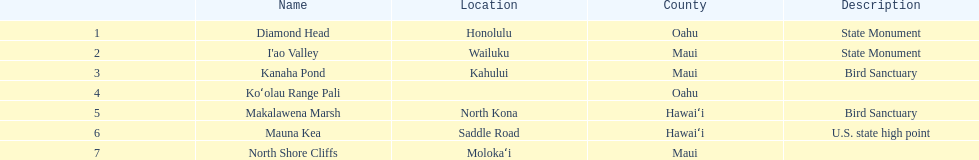Is kanaha pond a state landmark or a bird refuge? Bird Sanctuary. 